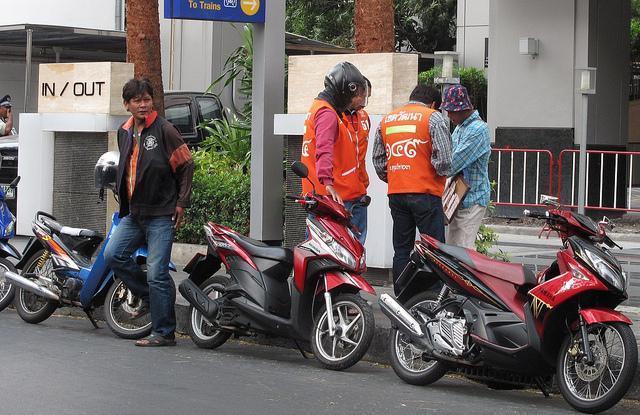How many cars are in this picture?
Give a very brief answer. 0. How many motorcycles are there?
Give a very brief answer. 3. How many people are there?
Give a very brief answer. 4. How many pizzas are the people holding?
Give a very brief answer. 0. 